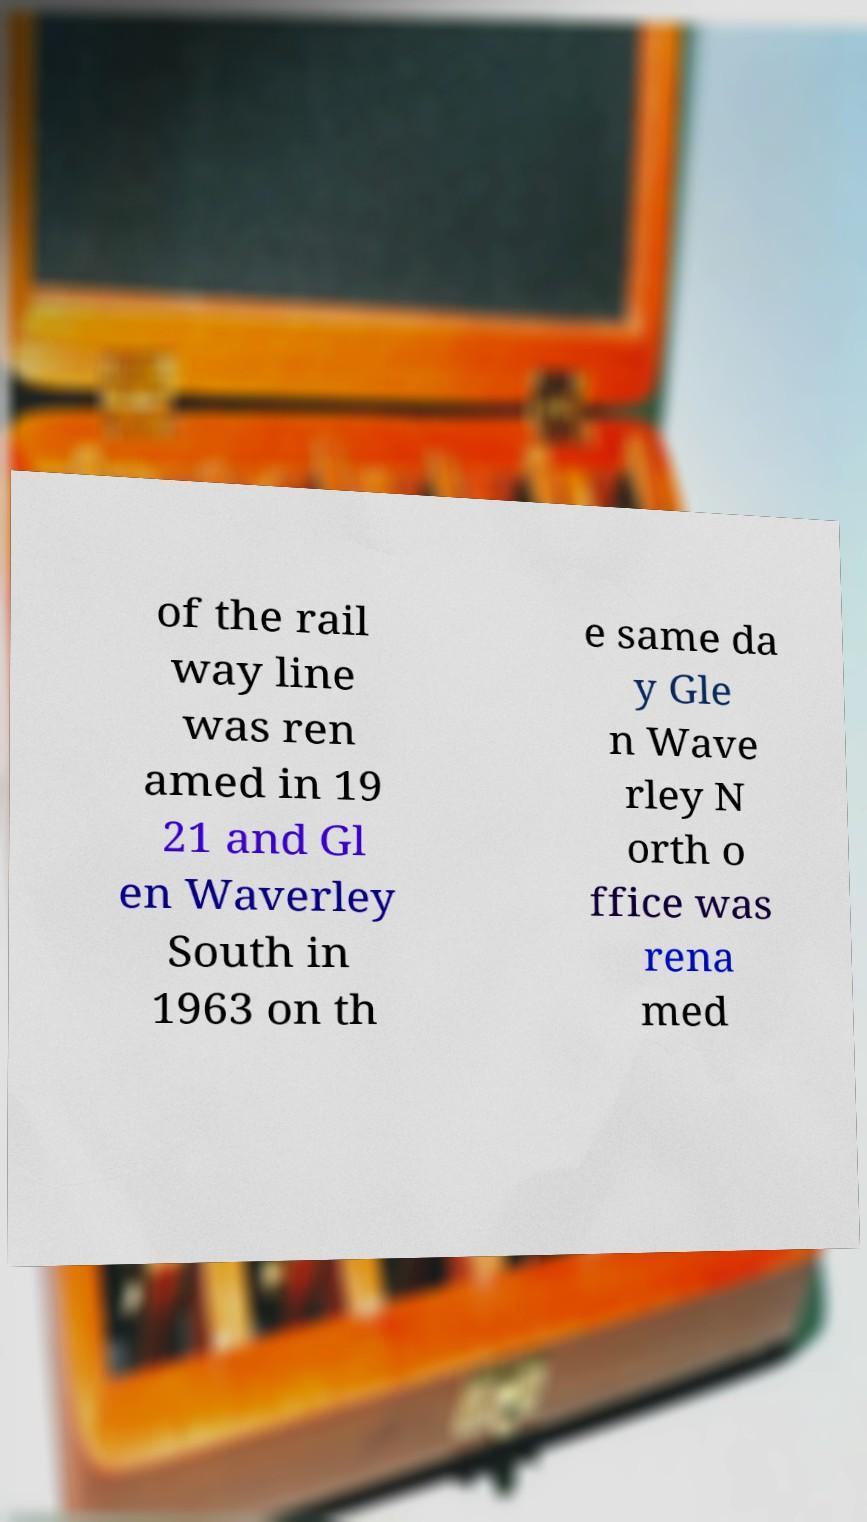Could you extract and type out the text from this image? of the rail way line was ren amed in 19 21 and Gl en Waverley South in 1963 on th e same da y Gle n Wave rley N orth o ffice was rena med 